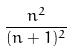<formula> <loc_0><loc_0><loc_500><loc_500>\frac { n ^ { 2 } } { ( n + 1 ) ^ { 2 } }</formula> 